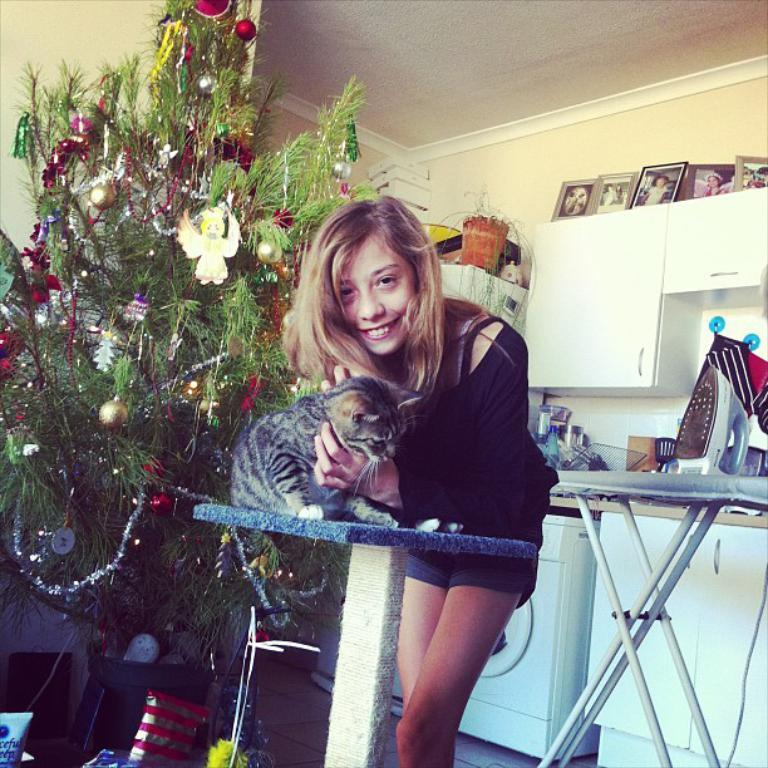Who is present in the image? There is a woman in the image. What is the woman holding in her hands? The woman is holding a cat in her hands. What is the woman's facial expression? The woman is smiling. What type of plant can be seen in the image? There is a plant in the image. What is the iron box used for? The iron box is likely used for storage or organization. What appliance is visible in the image? There is a washing machine in the image. What type of decorative items are present in the image? There are photo frames in the image. What type of ear is visible in the image? There is no ear present in the image. How many beds can be seen in the image? There are no beds visible in the image. 